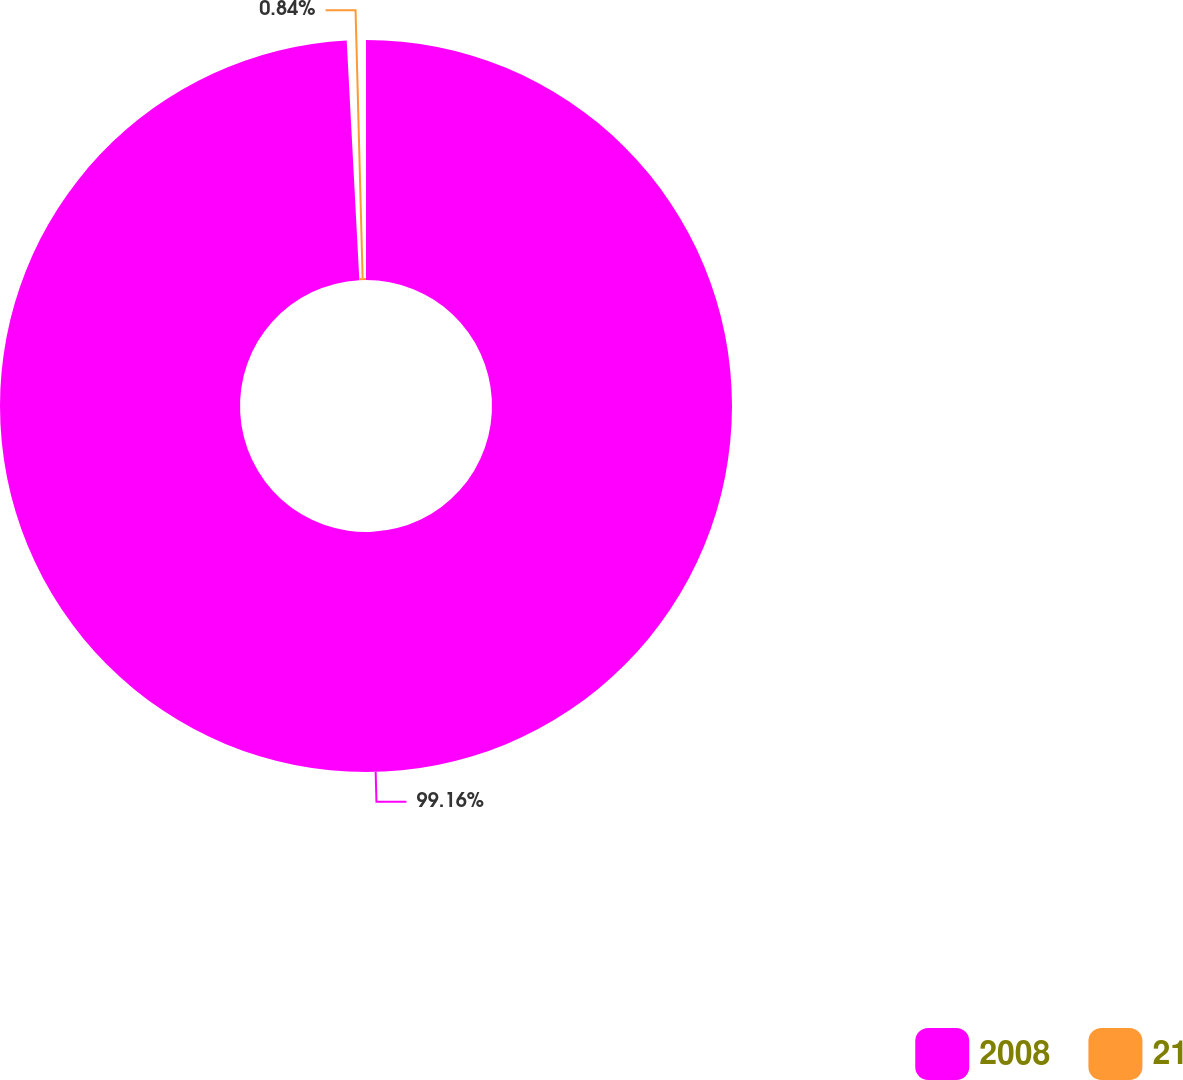Convert chart. <chart><loc_0><loc_0><loc_500><loc_500><pie_chart><fcel>2008<fcel>21<nl><fcel>99.16%<fcel>0.84%<nl></chart> 